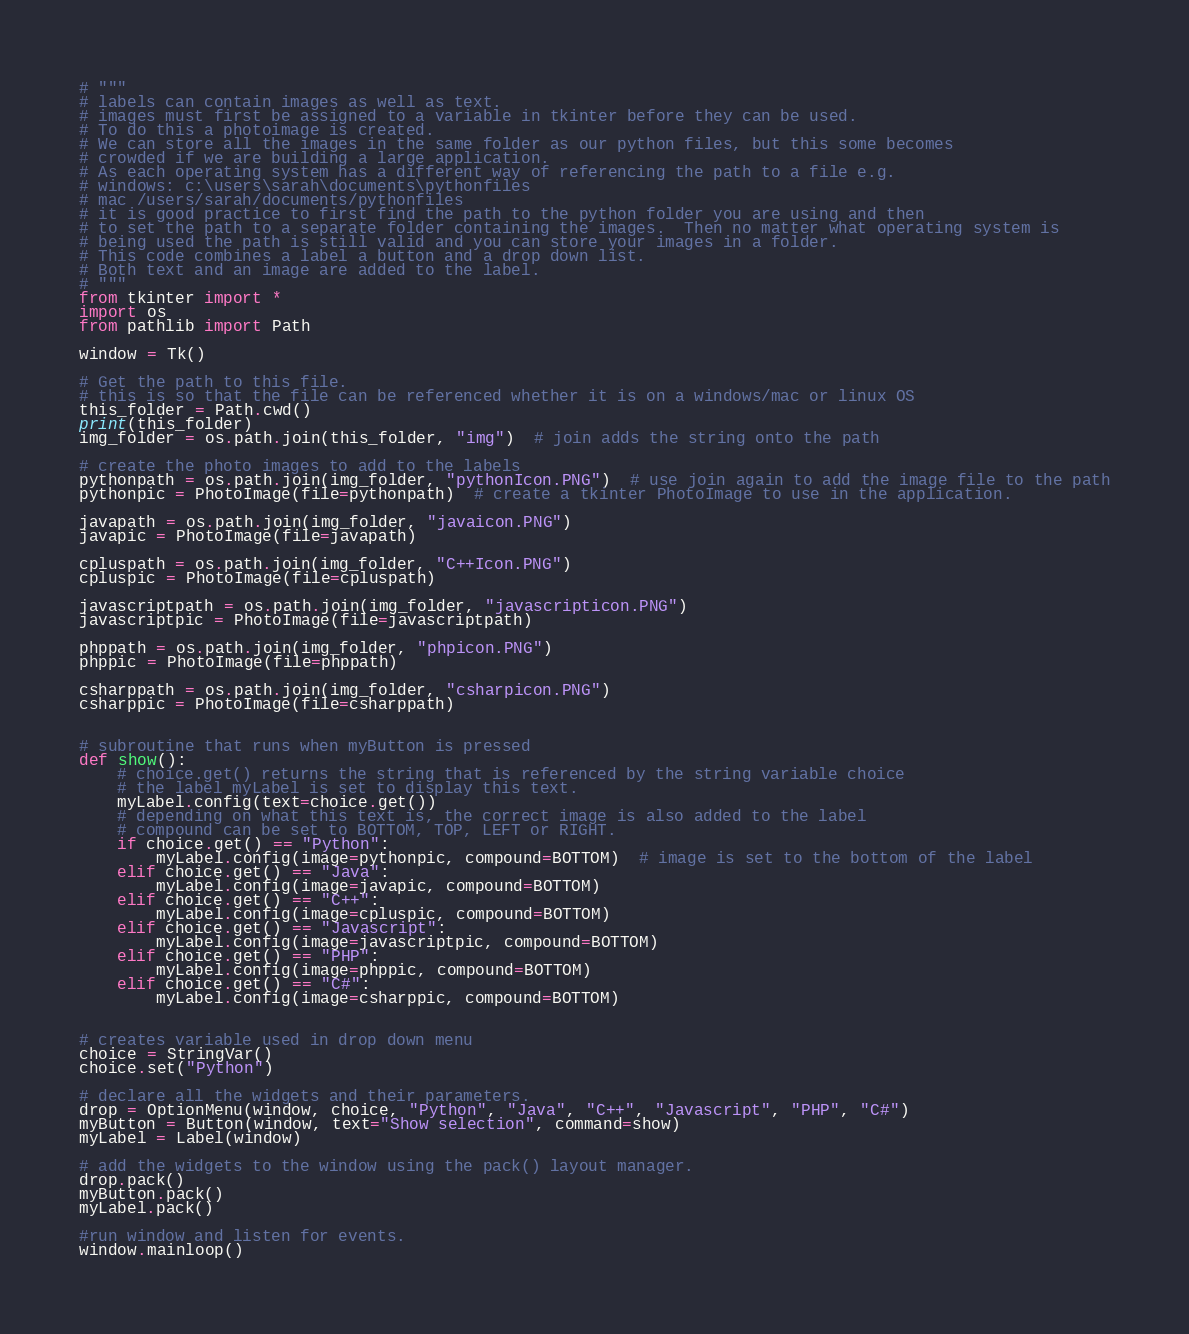Convert code to text. <code><loc_0><loc_0><loc_500><loc_500><_Python_># """
# labels can contain images as well as text.
# images must first be assigned to a variable in tkinter before they can be used.
# To do this a photoimage is created.
# We can store all the images in the same folder as our python files, but this some becomes
# crowded if we are building a large application.
# As each operating system has a different way of referencing the path to a file e.g.
# windows: c:\users\sarah\documents\pythonfiles
# mac /users/sarah/documents/pythonfiles
# it is good practice to first find the path to the python folder you are using and then
# to set the path to a separate folder containing the images.  Then no matter what operating system is
# being used the path is still valid and you can store your images in a folder.
# This code combines a label a button and a drop down list.
# Both text and an image are added to the label.
# """
from tkinter import *
import os
from pathlib import Path

window = Tk()

# Get the path to this file.
# this is so that the file can be referenced whether it is on a windows/mac or linux OS
this_folder = Path.cwd()
print(this_folder)
img_folder = os.path.join(this_folder, "img")  # join adds the string onto the path

# create the photo images to add to the labels
pythonpath = os.path.join(img_folder, "pythonIcon.PNG")  # use join again to add the image file to the path
pythonpic = PhotoImage(file=pythonpath)  # create a tkinter PhotoImage to use in the application.

javapath = os.path.join(img_folder, "javaicon.PNG")
javapic = PhotoImage(file=javapath)

cpluspath = os.path.join(img_folder, "C++Icon.PNG")
cpluspic = PhotoImage(file=cpluspath)

javascriptpath = os.path.join(img_folder, "javascripticon.PNG")
javascriptpic = PhotoImage(file=javascriptpath)

phppath = os.path.join(img_folder, "phpicon.PNG")
phppic = PhotoImage(file=phppath)

csharppath = os.path.join(img_folder, "csharpicon.PNG")
csharppic = PhotoImage(file=csharppath)


# subroutine that runs when myButton is pressed
def show():
	# choice.get() returns the string that is referenced by the string variable choice
	# the label myLabel is set to display this text.
	myLabel.config(text=choice.get())
	# depending on what this text is, the correct image is also added to the label
	# compound can be set to BOTTOM, TOP, LEFT or RIGHT.
	if choice.get() == "Python":
		myLabel.config(image=pythonpic, compound=BOTTOM)  # image is set to the bottom of the label
	elif choice.get() == "Java":
		myLabel.config(image=javapic, compound=BOTTOM)
	elif choice.get() == "C++":
		myLabel.config(image=cpluspic, compound=BOTTOM)
	elif choice.get() == "Javascript":
		myLabel.config(image=javascriptpic, compound=BOTTOM)
	elif choice.get() == "PHP":
		myLabel.config(image=phppic, compound=BOTTOM)
	elif choice.get() == "C#":
		myLabel.config(image=csharppic, compound=BOTTOM)


# creates variable used in drop down menu
choice = StringVar()
choice.set("Python")

# declare all the widgets and their parameters.
drop = OptionMenu(window, choice, "Python", "Java", "C++", "Javascript", "PHP", "C#")
myButton = Button(window, text="Show selection", command=show)
myLabel = Label(window)

# add the widgets to the window using the pack() layout manager.
drop.pack()
myButton.pack()
myLabel.pack()

#run window and listen for events.
window.mainloop()
</code> 